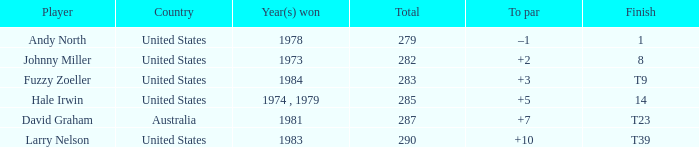Which athlete ended at +10? Larry Nelson. 